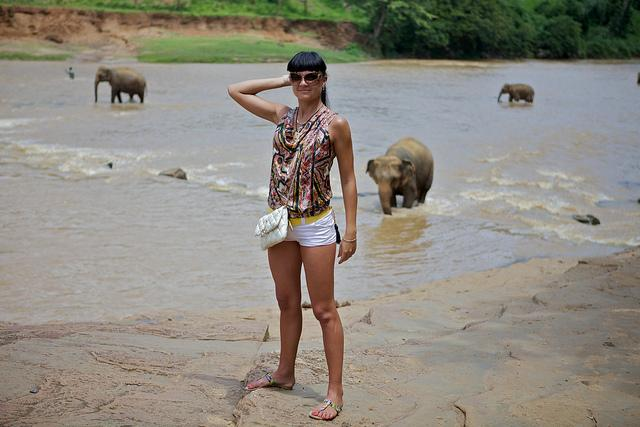Why is the woman holding her hand to her head?

Choices:
A) to direct
B) to wave
C) to pose
D) to dance to pose 